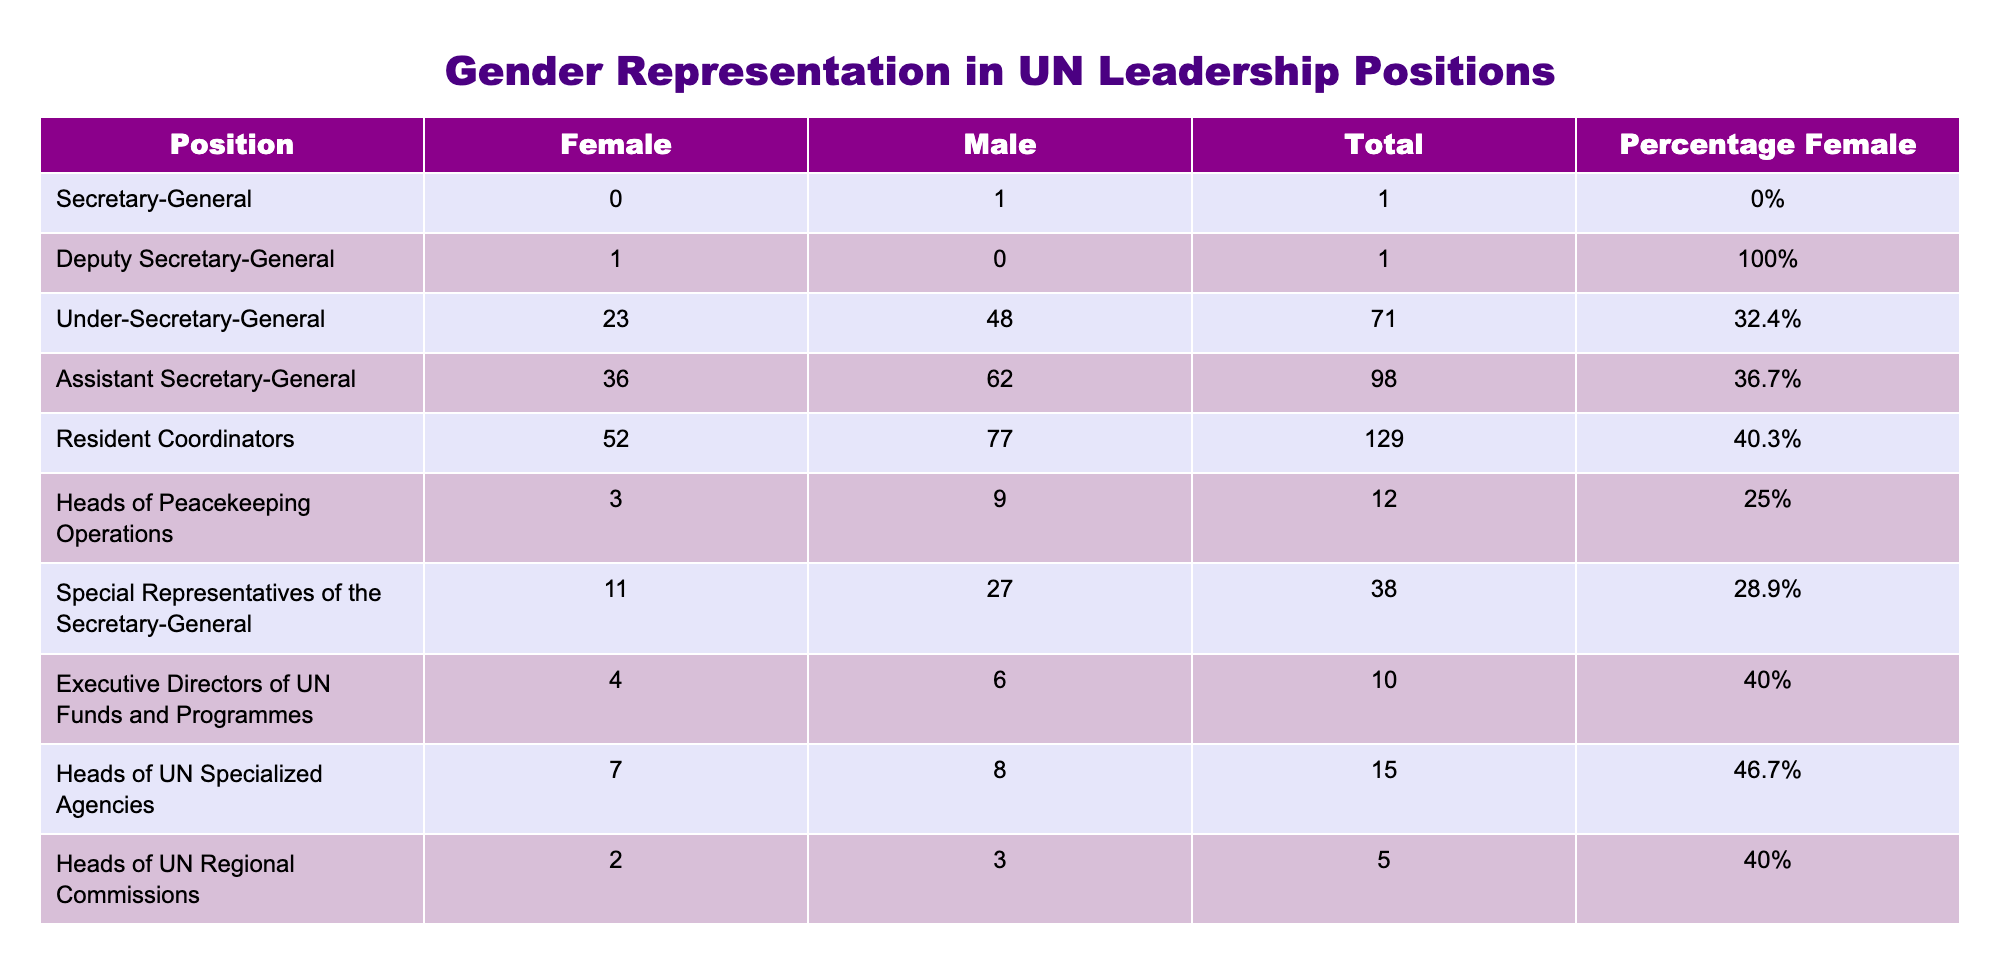What is the total number of Under-Secretaries-General? The table shows that there are 71 Under-Secretaries-General in total, with 23 female and 48 male individuals in this category.
Answer: 71 What percentage of Assistant Secretaries-General are female? According to the table, the percentage of female Assistant Secretaries-General is 36.7%.
Answer: 36.7% Is the Deputy Secretary-General a position occupied by a female? The table indicates that the Deputy Secretary-General position is occupied by a female, as shown by the "1" in the Female column and "0" in the Male column.
Answer: Yes How many more males than females are there among Heads of Peacekeeping Operations? From the table, there are 9 males and 3 females among Heads of Peacekeeping Operations. The difference is calculated as 9 - 3 = 6.
Answer: 6 What is the average percentage of females across all listed positions? To find the average percentage of females, we sum all the percentages of females (0% + 100% + 32.4% + 36.7% + 40.3% + 25% + 28.9% + 40% + 46.7% + 40%) which totals 350.0%. Then divide by the number of positions (10), which gives us 350.0 / 10 = 35%.
Answer: 35% How many total leadership positions are male-dominated, defined as having less than 40% female representation? Analyzing the percentages, the positions with less than 40% female representation are: Secretary-General (0%), Under-Secretary-General (32.4%), Heads of Peacekeeping Operations (25%), and Special Representatives of the Secretary-General (28.9%). This totals 4 positions.
Answer: 4 What is the total number of female Executive Directors of UN Funds and Programmes? The table clearly states that there are 4 female Executive Directors of UN Funds and Programmes.
Answer: 4 Is the total number of female Heads of UN Regional Commissions greater than the total number of female Heads of UN Specialized Agencies? According to the table, there are 2 female Heads of UN Regional Commissions and 7 female Heads of UN Specialized Agencies. Since 2 is not greater than 7, the statement is false.
Answer: No What is the total representation of females in Resident Coordinators? In the Resident Coordinators category, there are 52 females and the total is 129. Thus, the representation is explicitly stated as 40.3% in the table, which confirms the data.
Answer: 52 females 